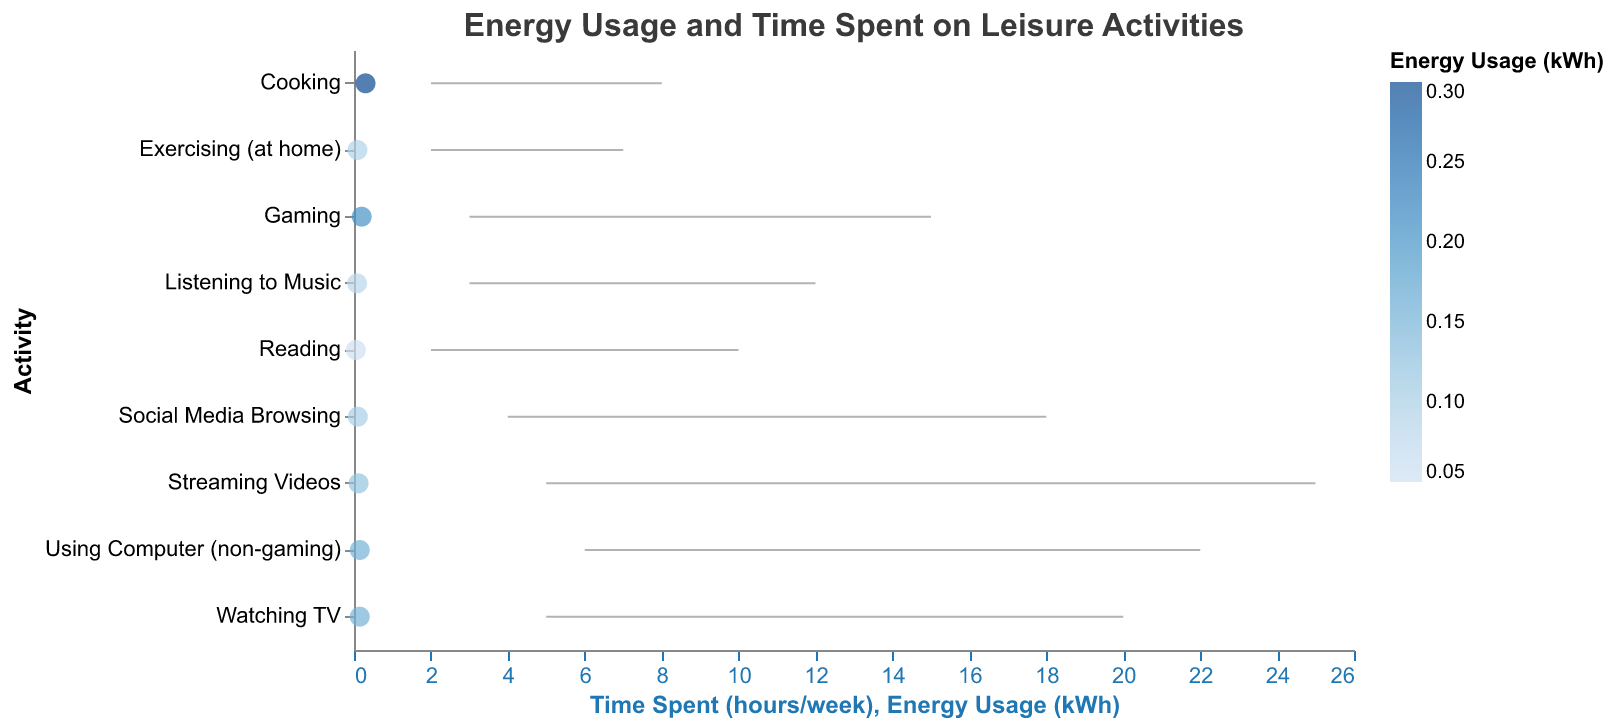What is the title of the chart? The title of the chart is usually placed at the top and is directly viewable. It reads, "Energy Usage and Time Spent on Leisure Activities".
Answer: Energy Usage and Time Spent on Leisure Activities Which activity has the highest maximum time spent per week? By examining the maximum time spent values on the x-axis across all activities, Streaming Videos has the highest maximum time spent of 25 hours per week.
Answer: Streaming Videos Which activity uses the least energy and how much energy does it use? The energy usage can be identified from the point's position on the x-axis. Reading, positioned at 0.05 kWh, is the activity with the least energy usage.
Answer: Reading (0.05 kWh) What is the range of time spent on exercising at home per week? By looking at the rule line of "Exercising (at home)" on the x-axis, it starts at 2 hours and ends at 7 hours. The range can be calculated as 7 - 2 = 5 hours.
Answer: 2 to 7 hours (5 hours range) How much more energy is used by Gaming compared to Listening to Music? The energy usage for Gaming is 0.20 kWh and for Listening to Music is 0.08 kWh. The difference is calculated as 0.20 - 0.08 = 0.12 kWh.
Answer: 0.12 kWh Which activity has the narrowest range of time spent on it per week? By examining the lengths of the rule lines across all activities, Cooking has the narrowest range, from 2 to 8 hours, giving it a range of 6 hours.
Answer: Cooking Compare the energy usage of Watching TV and Using Computer (non-gaming). Which one is higher? Watching TV and Using Computer (non-gaming) both have an energy usage of 0.15 kWh, so they are equal in energy usage.
Answer: Equal (0.15 kWh each) What is the average time spent on Social Media Browsing per week? The time range for Social Media Browsing is 4 to 18 hours. The average is calculated as (4 + 18) / 2 = 11 hours.
Answer: 11 hours How much energy is used for activities that have a maximum time spent of more than 20 hours per week? The activities with a maximum time spent of more than 20 hours are Using Computer (non-gaming) and Streaming Videos. Their energy usages are 0.15 kWh and 0.12 kWh, respectively. The total energy usage is 0.15 + 0.12 = 0.27 kWh.
Answer: 0.27 kWh Which activity has the same energy usage as Watching TV? Watching TV has an energy usage of 0.15 kWh. The other activity with the same energy usage is Using Computer (non-gaming).
Answer: Using Computer (non-gaming) 